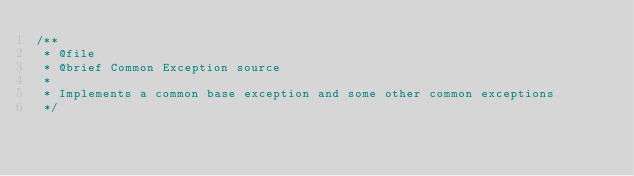<code> <loc_0><loc_0><loc_500><loc_500><_C++_>/**
 * @file
 * @brief Common Exception source
 *
 * Implements a common base exception and some other common exceptions
 */
</code> 